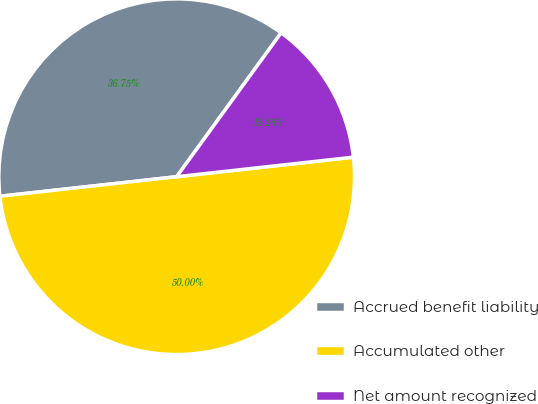Convert chart. <chart><loc_0><loc_0><loc_500><loc_500><pie_chart><fcel>Accrued benefit liability<fcel>Accumulated other<fcel>Net amount recognized<nl><fcel>36.75%<fcel>50.0%<fcel>13.25%<nl></chart> 